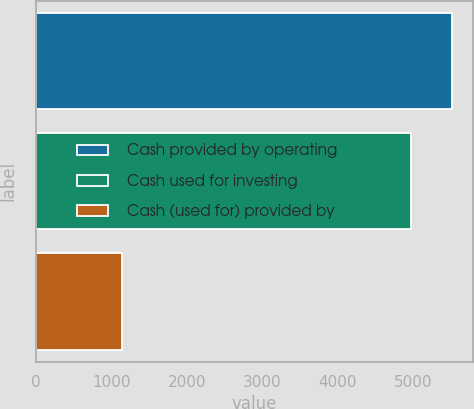Convert chart to OTSL. <chart><loc_0><loc_0><loc_500><loc_500><bar_chart><fcel>Cash provided by operating<fcel>Cash used for investing<fcel>Cash (used for) provided by<nl><fcel>5520<fcel>4971<fcel>1139<nl></chart> 